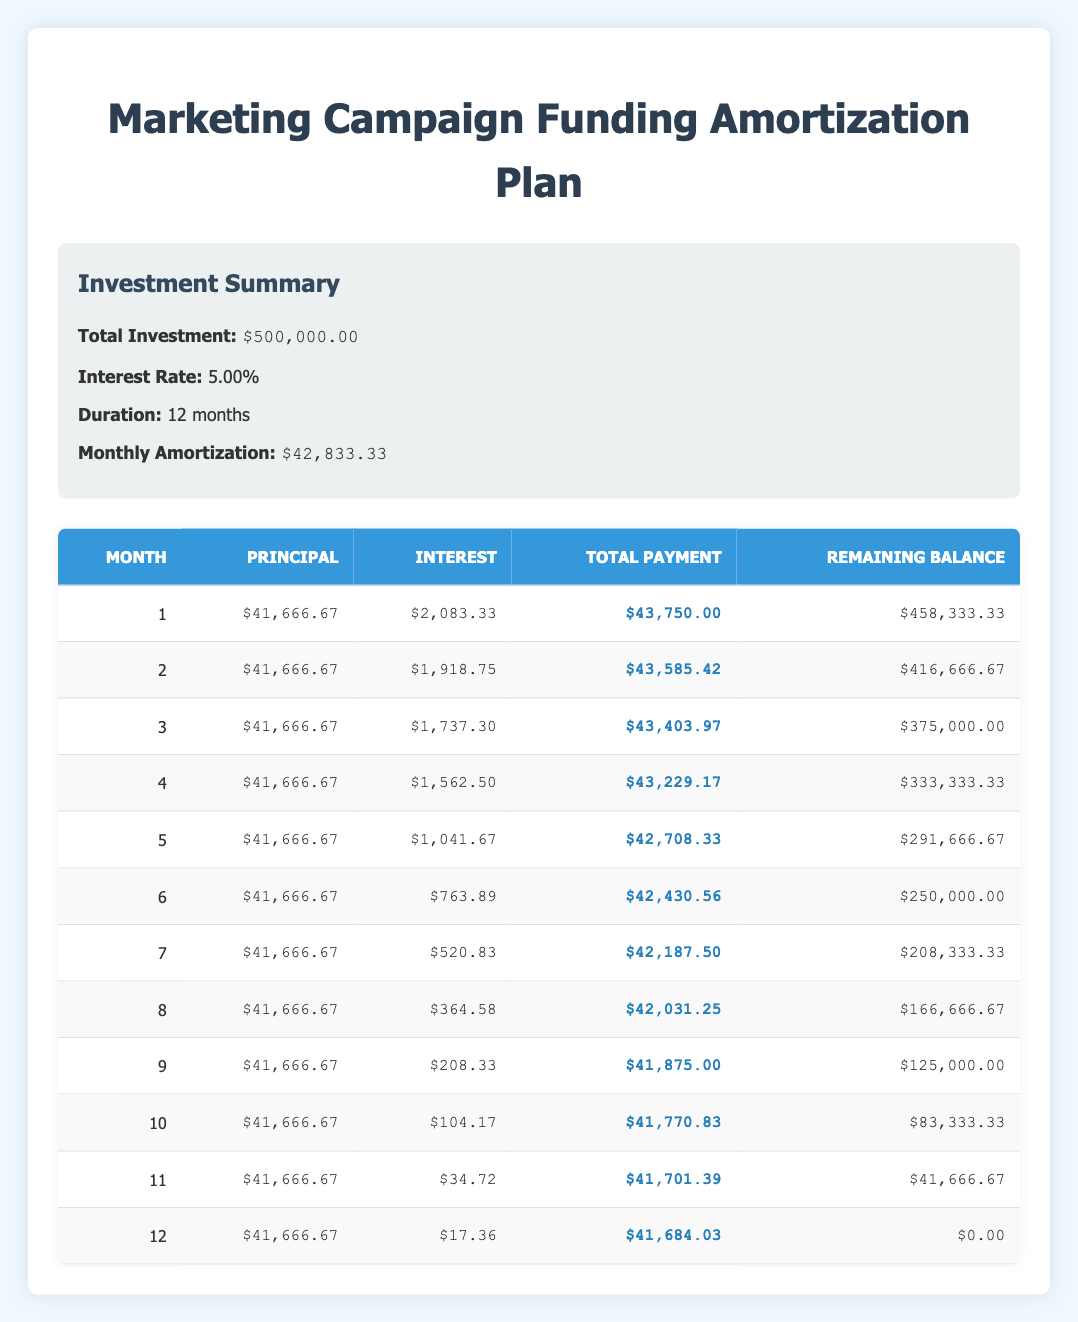What is the total investment in the marketing campaign? The table clearly states that the total investment is $500,000.00 in the investment summary section.
Answer: 500,000.00 What is the monthly amortization amount? In the investment summary, it is indicated that the monthly amortization is $42,833.33.
Answer: 42,833.33 How much principal is paid in the 4th month? In the payment schedule, for the 4th month, the principal is listed as $41,666.67.
Answer: 41,666.67 What is the total payment made in the 9th month? Looking at the 9th month's row in the table, the total payment made is $41,875.00.
Answer: 41,875.00 What is the remaining balance after the 6th month? The table shows that after the 6th month, the remaining balance is $250,000.00.
Answer: 250,000.00 What is the total interest paid over the 12 months? To find the total interest paid, sum the interest amounts from all 12 months. Adding the monthly interest gives (2083.33 + 1918.75 + 1737.30 + 1562.50 + 1041.67 + 763.89 + 520.83 + 364.58 + 208.33 + 104.17 + 34.72 + 17.36) = $11,263.81.
Answer: 11,263.81 Does the interest amount decrease each month? Observing the interest amounts for each month, we see they consistently decrease: from $2,083.33 to $17.36. Thus, it is confirmed that the interest amount decreases each month.
Answer: Yes What is the difference between the total payment in the 1st month and the total payment in the 12th month? The total payment in the 1st month is $43,750.00 and in the 12th month it’s $41,684.03. The difference is $43,750.00 - $41,684.03 = $2,065.97.
Answer: 2065.97 How much interest is paid in the 11th month compared to the 1st month? The interest paid in the 1st month is $2,083.33, and in the 11th month, it is $34.72. The comparison shows that the interest was significantly higher in the 1st month than in the 11th month.
Answer: Much higher in the 1st month 